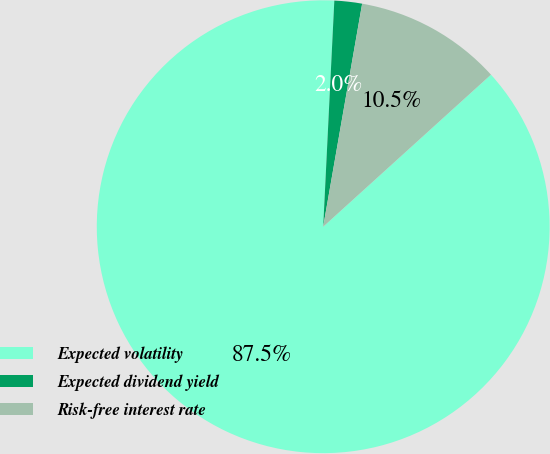Convert chart. <chart><loc_0><loc_0><loc_500><loc_500><pie_chart><fcel>Expected volatility<fcel>Expected dividend yield<fcel>Risk-free interest rate<nl><fcel>87.51%<fcel>1.97%<fcel>10.53%<nl></chart> 